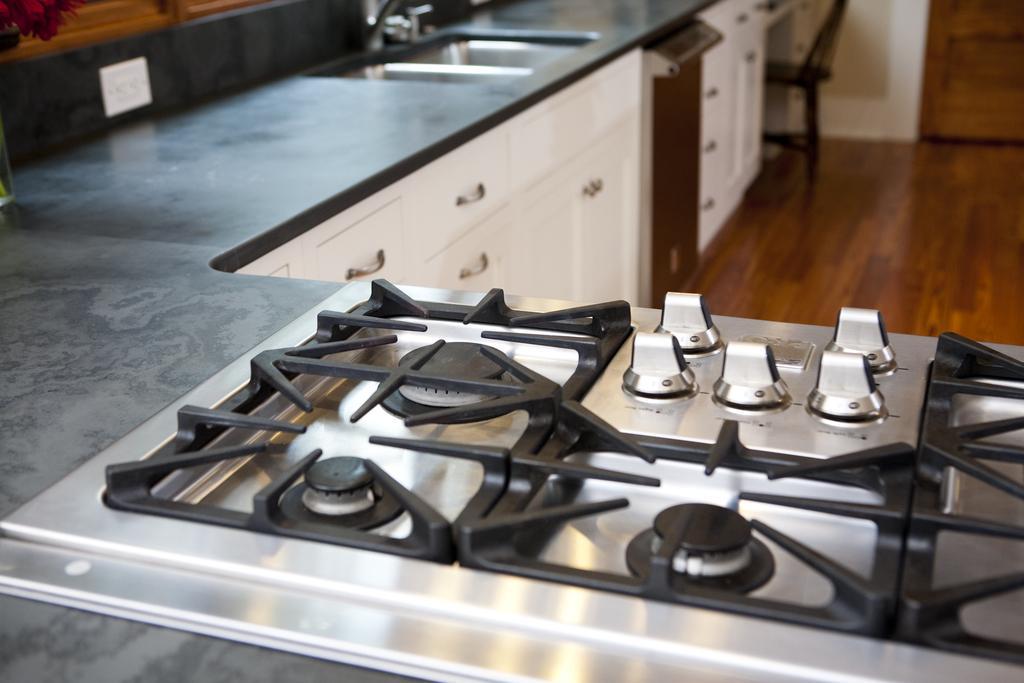Describe this image in one or two sentences. There is a stove in the front. There is a wash basin and there are cupboards below it. There is a chair at the back and there is a wooden surface. 